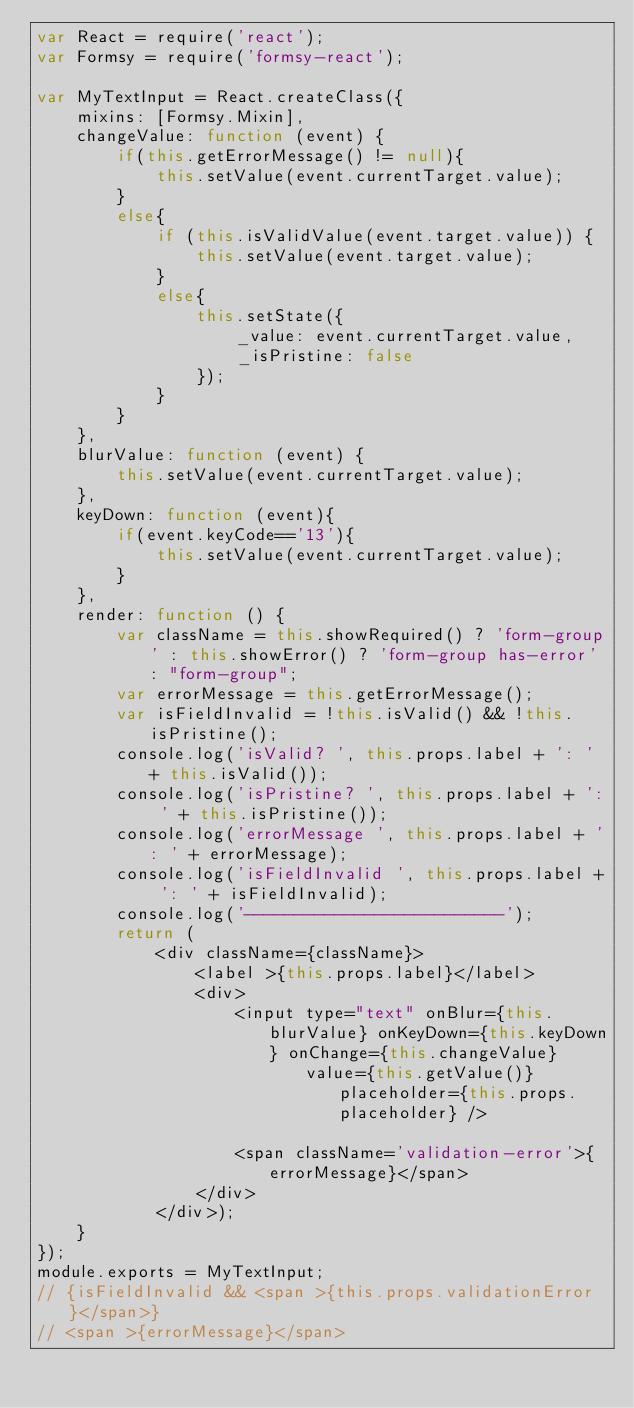<code> <loc_0><loc_0><loc_500><loc_500><_JavaScript_>var React = require('react');
var Formsy = require('formsy-react');

var MyTextInput = React.createClass({
    mixins: [Formsy.Mixin],
    changeValue: function (event) {
        if(this.getErrorMessage() != null){
            this.setValue(event.currentTarget.value);
        }
        else{
            if (this.isValidValue(event.target.value)) {
                this.setValue(event.target.value);
            }
            else{
                this.setState({
                    _value: event.currentTarget.value,
                    _isPristine: false
                });
            }
        }
    },
    blurValue: function (event) {
        this.setValue(event.currentTarget.value);
    },
    keyDown: function (event){
        if(event.keyCode=='13'){
            this.setValue(event.currentTarget.value);
        }
    },
    render: function () {
        var className = this.showRequired() ? 'form-group' : this.showError() ? 'form-group has-error' : "form-group";
        var errorMessage = this.getErrorMessage();
        var isFieldInvalid = !this.isValid() && !this.isPristine();
        console.log('isValid? ', this.props.label + ': ' + this.isValid());
        console.log('isPristine? ', this.props.label + ': ' + this.isPristine());
        console.log('errorMessage ', this.props.label + ': ' + errorMessage);
        console.log('isFieldInvalid ', this.props.label + ': ' + isFieldInvalid);
        console.log('--------------------------');
        return (
            <div className={className}>
                <label >{this.props.label}</label>
                <div>
                    <input type="text" onBlur={this.blurValue} onKeyDown={this.keyDown} onChange={this.changeValue}
                           value={this.getValue()} placeholder={this.props.placeholder} />
                    
                    <span className='validation-error'>{errorMessage}</span>
                </div>
            </div>);
    }
});
module.exports = MyTextInput;
// {isFieldInvalid && <span >{this.props.validationError}</span>}
// <span >{errorMessage}</span>
</code> 